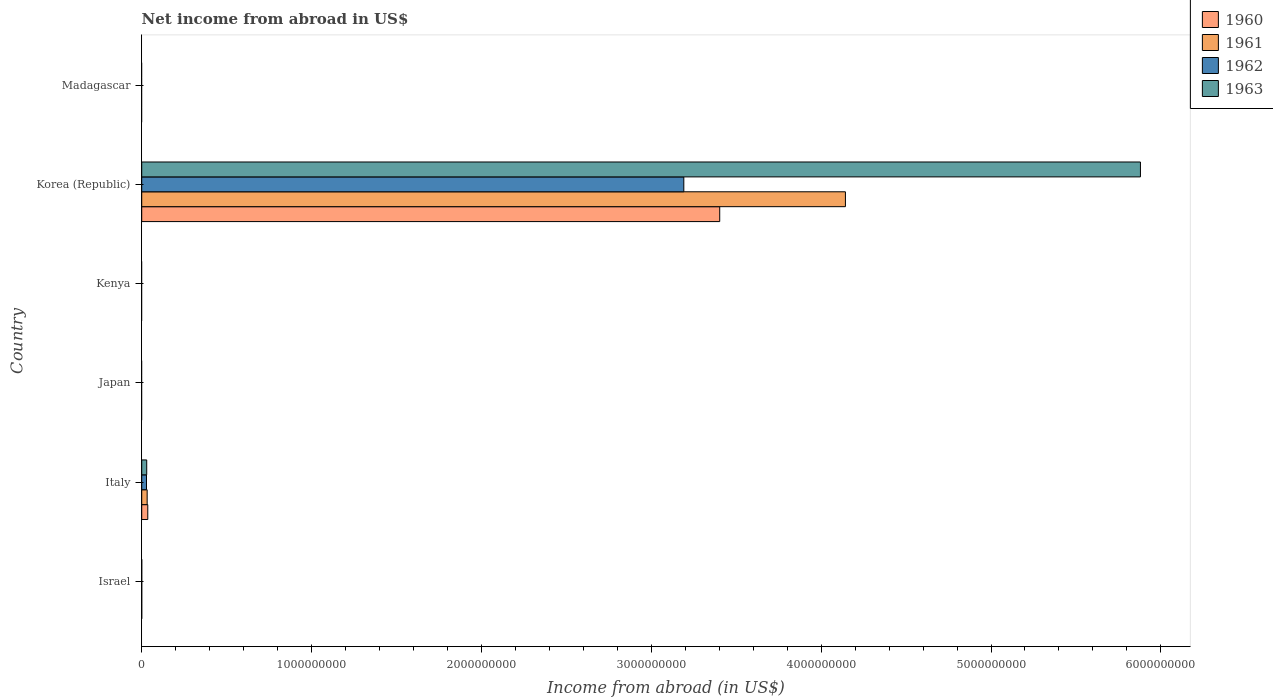Are the number of bars per tick equal to the number of legend labels?
Your answer should be very brief. No. Are the number of bars on each tick of the Y-axis equal?
Ensure brevity in your answer.  No. What is the label of the 5th group of bars from the top?
Your answer should be compact. Italy. Across all countries, what is the maximum net income from abroad in 1961?
Your response must be concise. 4.14e+09. Across all countries, what is the minimum net income from abroad in 1960?
Your answer should be very brief. 0. In which country was the net income from abroad in 1962 maximum?
Your answer should be very brief. Korea (Republic). What is the total net income from abroad in 1962 in the graph?
Offer a terse response. 3.22e+09. What is the difference between the net income from abroad in 1961 in Italy and the net income from abroad in 1960 in Korea (Republic)?
Provide a short and direct response. -3.37e+09. What is the average net income from abroad in 1962 per country?
Keep it short and to the point. 5.37e+08. What is the difference between the net income from abroad in 1963 and net income from abroad in 1961 in Korea (Republic)?
Give a very brief answer. 1.74e+09. In how many countries, is the net income from abroad in 1960 greater than 400000000 US$?
Your answer should be very brief. 1. What is the ratio of the net income from abroad in 1963 in Italy to that in Korea (Republic)?
Your answer should be compact. 0.01. What is the difference between the highest and the lowest net income from abroad in 1961?
Offer a very short reply. 4.14e+09. In how many countries, is the net income from abroad in 1963 greater than the average net income from abroad in 1963 taken over all countries?
Offer a very short reply. 1. Is the sum of the net income from abroad in 1962 in Italy and Korea (Republic) greater than the maximum net income from abroad in 1963 across all countries?
Your answer should be very brief. No. Is it the case that in every country, the sum of the net income from abroad in 1961 and net income from abroad in 1962 is greater than the sum of net income from abroad in 1963 and net income from abroad in 1960?
Keep it short and to the point. No. Is it the case that in every country, the sum of the net income from abroad in 1963 and net income from abroad in 1961 is greater than the net income from abroad in 1960?
Provide a succinct answer. No. Are all the bars in the graph horizontal?
Provide a short and direct response. Yes. Does the graph contain grids?
Offer a very short reply. No. Where does the legend appear in the graph?
Provide a succinct answer. Top right. How many legend labels are there?
Provide a succinct answer. 4. What is the title of the graph?
Offer a terse response. Net income from abroad in US$. What is the label or title of the X-axis?
Provide a short and direct response. Income from abroad (in US$). What is the label or title of the Y-axis?
Your response must be concise. Country. What is the Income from abroad (in US$) of 1962 in Israel?
Your answer should be compact. 0. What is the Income from abroad (in US$) in 1960 in Italy?
Your answer should be compact. 3.56e+07. What is the Income from abroad (in US$) in 1961 in Italy?
Keep it short and to the point. 3.20e+07. What is the Income from abroad (in US$) of 1962 in Italy?
Keep it short and to the point. 2.82e+07. What is the Income from abroad (in US$) of 1963 in Italy?
Provide a succinct answer. 2.94e+07. What is the Income from abroad (in US$) in 1961 in Japan?
Provide a short and direct response. 0. What is the Income from abroad (in US$) of 1962 in Japan?
Provide a short and direct response. 0. What is the Income from abroad (in US$) of 1960 in Kenya?
Provide a short and direct response. 0. What is the Income from abroad (in US$) of 1961 in Kenya?
Provide a succinct answer. 0. What is the Income from abroad (in US$) of 1960 in Korea (Republic)?
Provide a succinct answer. 3.40e+09. What is the Income from abroad (in US$) of 1961 in Korea (Republic)?
Provide a short and direct response. 4.14e+09. What is the Income from abroad (in US$) of 1962 in Korea (Republic)?
Make the answer very short. 3.19e+09. What is the Income from abroad (in US$) of 1963 in Korea (Republic)?
Your answer should be very brief. 5.88e+09. What is the Income from abroad (in US$) of 1960 in Madagascar?
Your answer should be very brief. 0. What is the Income from abroad (in US$) of 1961 in Madagascar?
Give a very brief answer. 0. What is the Income from abroad (in US$) in 1963 in Madagascar?
Your answer should be compact. 0. Across all countries, what is the maximum Income from abroad (in US$) in 1960?
Your response must be concise. 3.40e+09. Across all countries, what is the maximum Income from abroad (in US$) of 1961?
Give a very brief answer. 4.14e+09. Across all countries, what is the maximum Income from abroad (in US$) in 1962?
Provide a short and direct response. 3.19e+09. Across all countries, what is the maximum Income from abroad (in US$) in 1963?
Ensure brevity in your answer.  5.88e+09. Across all countries, what is the minimum Income from abroad (in US$) in 1960?
Ensure brevity in your answer.  0. Across all countries, what is the minimum Income from abroad (in US$) of 1961?
Ensure brevity in your answer.  0. Across all countries, what is the minimum Income from abroad (in US$) in 1962?
Your answer should be compact. 0. What is the total Income from abroad (in US$) in 1960 in the graph?
Your answer should be very brief. 3.44e+09. What is the total Income from abroad (in US$) in 1961 in the graph?
Provide a short and direct response. 4.17e+09. What is the total Income from abroad (in US$) of 1962 in the graph?
Your answer should be very brief. 3.22e+09. What is the total Income from abroad (in US$) in 1963 in the graph?
Offer a very short reply. 5.91e+09. What is the difference between the Income from abroad (in US$) of 1960 in Italy and that in Korea (Republic)?
Your response must be concise. -3.37e+09. What is the difference between the Income from abroad (in US$) in 1961 in Italy and that in Korea (Republic)?
Keep it short and to the point. -4.11e+09. What is the difference between the Income from abroad (in US$) of 1962 in Italy and that in Korea (Republic)?
Provide a short and direct response. -3.16e+09. What is the difference between the Income from abroad (in US$) in 1963 in Italy and that in Korea (Republic)?
Give a very brief answer. -5.85e+09. What is the difference between the Income from abroad (in US$) of 1960 in Italy and the Income from abroad (in US$) of 1961 in Korea (Republic)?
Offer a terse response. -4.11e+09. What is the difference between the Income from abroad (in US$) of 1960 in Italy and the Income from abroad (in US$) of 1962 in Korea (Republic)?
Give a very brief answer. -3.16e+09. What is the difference between the Income from abroad (in US$) in 1960 in Italy and the Income from abroad (in US$) in 1963 in Korea (Republic)?
Your answer should be very brief. -5.84e+09. What is the difference between the Income from abroad (in US$) of 1961 in Italy and the Income from abroad (in US$) of 1962 in Korea (Republic)?
Your answer should be compact. -3.16e+09. What is the difference between the Income from abroad (in US$) in 1961 in Italy and the Income from abroad (in US$) in 1963 in Korea (Republic)?
Your answer should be compact. -5.85e+09. What is the difference between the Income from abroad (in US$) of 1962 in Italy and the Income from abroad (in US$) of 1963 in Korea (Republic)?
Your answer should be very brief. -5.85e+09. What is the average Income from abroad (in US$) in 1960 per country?
Keep it short and to the point. 5.73e+08. What is the average Income from abroad (in US$) in 1961 per country?
Provide a short and direct response. 6.96e+08. What is the average Income from abroad (in US$) of 1962 per country?
Your answer should be very brief. 5.37e+08. What is the average Income from abroad (in US$) in 1963 per country?
Provide a succinct answer. 9.85e+08. What is the difference between the Income from abroad (in US$) in 1960 and Income from abroad (in US$) in 1961 in Italy?
Your answer should be compact. 3.67e+06. What is the difference between the Income from abroad (in US$) in 1960 and Income from abroad (in US$) in 1962 in Italy?
Offer a very short reply. 7.48e+06. What is the difference between the Income from abroad (in US$) of 1960 and Income from abroad (in US$) of 1963 in Italy?
Offer a very short reply. 6.24e+06. What is the difference between the Income from abroad (in US$) of 1961 and Income from abroad (in US$) of 1962 in Italy?
Ensure brevity in your answer.  3.82e+06. What is the difference between the Income from abroad (in US$) in 1961 and Income from abroad (in US$) in 1963 in Italy?
Offer a very short reply. 2.58e+06. What is the difference between the Income from abroad (in US$) in 1962 and Income from abroad (in US$) in 1963 in Italy?
Your response must be concise. -1.24e+06. What is the difference between the Income from abroad (in US$) of 1960 and Income from abroad (in US$) of 1961 in Korea (Republic)?
Give a very brief answer. -7.40e+08. What is the difference between the Income from abroad (in US$) of 1960 and Income from abroad (in US$) of 1962 in Korea (Republic)?
Offer a terse response. 2.11e+08. What is the difference between the Income from abroad (in US$) of 1960 and Income from abroad (in US$) of 1963 in Korea (Republic)?
Your response must be concise. -2.48e+09. What is the difference between the Income from abroad (in US$) of 1961 and Income from abroad (in US$) of 1962 in Korea (Republic)?
Keep it short and to the point. 9.52e+08. What is the difference between the Income from abroad (in US$) of 1961 and Income from abroad (in US$) of 1963 in Korea (Republic)?
Provide a short and direct response. -1.74e+09. What is the difference between the Income from abroad (in US$) of 1962 and Income from abroad (in US$) of 1963 in Korea (Republic)?
Offer a terse response. -2.69e+09. What is the ratio of the Income from abroad (in US$) in 1960 in Italy to that in Korea (Republic)?
Make the answer very short. 0.01. What is the ratio of the Income from abroad (in US$) in 1961 in Italy to that in Korea (Republic)?
Provide a short and direct response. 0.01. What is the ratio of the Income from abroad (in US$) in 1962 in Italy to that in Korea (Republic)?
Your answer should be very brief. 0.01. What is the ratio of the Income from abroad (in US$) of 1963 in Italy to that in Korea (Republic)?
Your response must be concise. 0.01. What is the difference between the highest and the lowest Income from abroad (in US$) in 1960?
Give a very brief answer. 3.40e+09. What is the difference between the highest and the lowest Income from abroad (in US$) of 1961?
Your answer should be very brief. 4.14e+09. What is the difference between the highest and the lowest Income from abroad (in US$) of 1962?
Offer a very short reply. 3.19e+09. What is the difference between the highest and the lowest Income from abroad (in US$) in 1963?
Make the answer very short. 5.88e+09. 